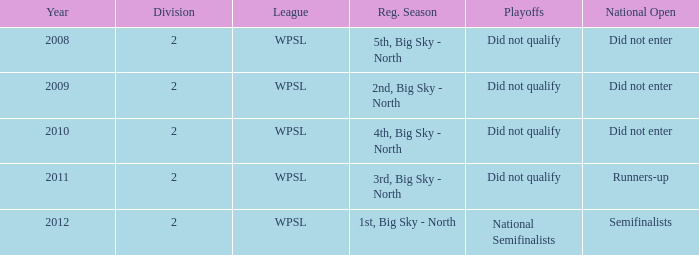What is the lowest division number? 2.0. 